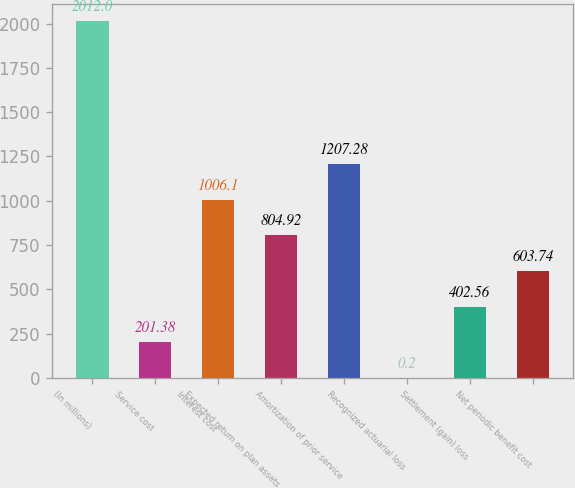<chart> <loc_0><loc_0><loc_500><loc_500><bar_chart><fcel>(In millions)<fcel>Service cost<fcel>Interest cost<fcel>Expected return on plan assets<fcel>Amortization of prior service<fcel>Recognized actuarial loss<fcel>Settlement (gain) loss<fcel>Net periodic benefit cost<nl><fcel>2012<fcel>201.38<fcel>1006.1<fcel>804.92<fcel>1207.28<fcel>0.2<fcel>402.56<fcel>603.74<nl></chart> 